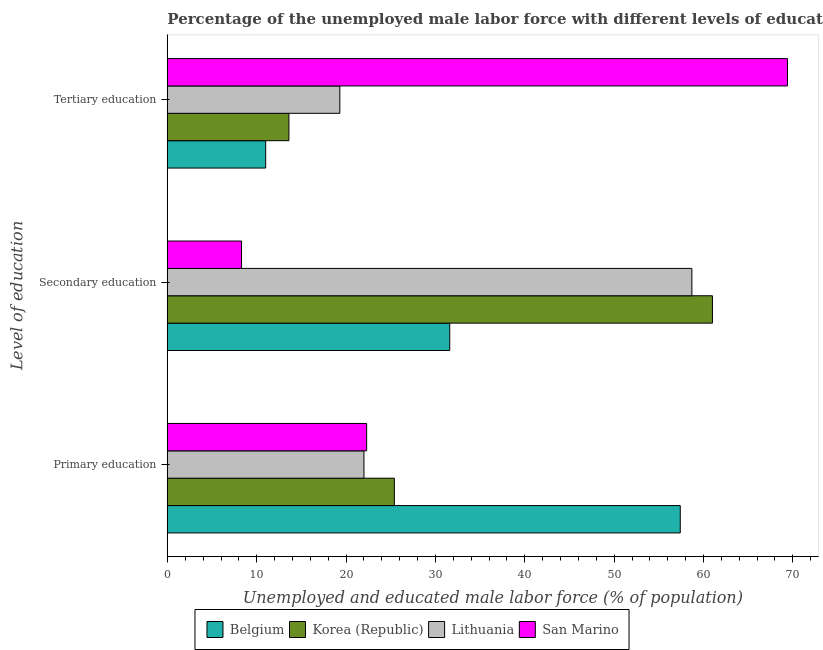How many groups of bars are there?
Make the answer very short. 3. Are the number of bars per tick equal to the number of legend labels?
Your answer should be compact. Yes. How many bars are there on the 3rd tick from the bottom?
Make the answer very short. 4. What is the label of the 1st group of bars from the top?
Provide a succinct answer. Tertiary education. What is the percentage of male labor force who received secondary education in Belgium?
Provide a succinct answer. 31.6. Across all countries, what is the maximum percentage of male labor force who received tertiary education?
Provide a short and direct response. 69.4. In which country was the percentage of male labor force who received primary education maximum?
Provide a succinct answer. Belgium. In which country was the percentage of male labor force who received tertiary education minimum?
Offer a terse response. Belgium. What is the total percentage of male labor force who received primary education in the graph?
Provide a succinct answer. 127.1. What is the difference between the percentage of male labor force who received secondary education in Belgium and that in Lithuania?
Offer a very short reply. -27.1. What is the difference between the percentage of male labor force who received secondary education in Lithuania and the percentage of male labor force who received primary education in Belgium?
Ensure brevity in your answer.  1.3. What is the average percentage of male labor force who received secondary education per country?
Keep it short and to the point. 39.9. What is the difference between the percentage of male labor force who received secondary education and percentage of male labor force who received primary education in Korea (Republic)?
Offer a very short reply. 35.6. In how many countries, is the percentage of male labor force who received primary education greater than 14 %?
Provide a succinct answer. 4. What is the ratio of the percentage of male labor force who received tertiary education in Belgium to that in Lithuania?
Your response must be concise. 0.57. Is the percentage of male labor force who received primary education in San Marino less than that in Korea (Republic)?
Ensure brevity in your answer.  Yes. What is the difference between the highest and the second highest percentage of male labor force who received primary education?
Ensure brevity in your answer.  32. What is the difference between the highest and the lowest percentage of male labor force who received tertiary education?
Give a very brief answer. 58.4. Is the sum of the percentage of male labor force who received tertiary education in Korea (Republic) and San Marino greater than the maximum percentage of male labor force who received primary education across all countries?
Give a very brief answer. Yes. What does the 4th bar from the bottom in Tertiary education represents?
Make the answer very short. San Marino. Is it the case that in every country, the sum of the percentage of male labor force who received primary education and percentage of male labor force who received secondary education is greater than the percentage of male labor force who received tertiary education?
Your response must be concise. No. Does the graph contain any zero values?
Keep it short and to the point. No. Does the graph contain grids?
Your response must be concise. No. Where does the legend appear in the graph?
Offer a terse response. Bottom center. How are the legend labels stacked?
Offer a very short reply. Horizontal. What is the title of the graph?
Make the answer very short. Percentage of the unemployed male labor force with different levels of education in countries. Does "Iran" appear as one of the legend labels in the graph?
Provide a short and direct response. No. What is the label or title of the X-axis?
Your response must be concise. Unemployed and educated male labor force (% of population). What is the label or title of the Y-axis?
Make the answer very short. Level of education. What is the Unemployed and educated male labor force (% of population) in Belgium in Primary education?
Provide a short and direct response. 57.4. What is the Unemployed and educated male labor force (% of population) of Korea (Republic) in Primary education?
Ensure brevity in your answer.  25.4. What is the Unemployed and educated male labor force (% of population) of Lithuania in Primary education?
Provide a short and direct response. 22. What is the Unemployed and educated male labor force (% of population) in San Marino in Primary education?
Your response must be concise. 22.3. What is the Unemployed and educated male labor force (% of population) of Belgium in Secondary education?
Ensure brevity in your answer.  31.6. What is the Unemployed and educated male labor force (% of population) in Lithuania in Secondary education?
Make the answer very short. 58.7. What is the Unemployed and educated male labor force (% of population) of San Marino in Secondary education?
Provide a short and direct response. 8.3. What is the Unemployed and educated male labor force (% of population) in Belgium in Tertiary education?
Your answer should be compact. 11. What is the Unemployed and educated male labor force (% of population) of Korea (Republic) in Tertiary education?
Ensure brevity in your answer.  13.6. What is the Unemployed and educated male labor force (% of population) of Lithuania in Tertiary education?
Offer a very short reply. 19.3. What is the Unemployed and educated male labor force (% of population) in San Marino in Tertiary education?
Ensure brevity in your answer.  69.4. Across all Level of education, what is the maximum Unemployed and educated male labor force (% of population) of Belgium?
Ensure brevity in your answer.  57.4. Across all Level of education, what is the maximum Unemployed and educated male labor force (% of population) of Korea (Republic)?
Offer a very short reply. 61. Across all Level of education, what is the maximum Unemployed and educated male labor force (% of population) of Lithuania?
Your answer should be very brief. 58.7. Across all Level of education, what is the maximum Unemployed and educated male labor force (% of population) of San Marino?
Ensure brevity in your answer.  69.4. Across all Level of education, what is the minimum Unemployed and educated male labor force (% of population) of Korea (Republic)?
Offer a terse response. 13.6. Across all Level of education, what is the minimum Unemployed and educated male labor force (% of population) of Lithuania?
Offer a very short reply. 19.3. Across all Level of education, what is the minimum Unemployed and educated male labor force (% of population) in San Marino?
Offer a very short reply. 8.3. What is the total Unemployed and educated male labor force (% of population) of Belgium in the graph?
Give a very brief answer. 100. What is the total Unemployed and educated male labor force (% of population) of Lithuania in the graph?
Provide a short and direct response. 100. What is the total Unemployed and educated male labor force (% of population) in San Marino in the graph?
Your response must be concise. 100. What is the difference between the Unemployed and educated male labor force (% of population) of Belgium in Primary education and that in Secondary education?
Offer a terse response. 25.8. What is the difference between the Unemployed and educated male labor force (% of population) in Korea (Republic) in Primary education and that in Secondary education?
Offer a very short reply. -35.6. What is the difference between the Unemployed and educated male labor force (% of population) of Lithuania in Primary education and that in Secondary education?
Ensure brevity in your answer.  -36.7. What is the difference between the Unemployed and educated male labor force (% of population) of San Marino in Primary education and that in Secondary education?
Provide a short and direct response. 14. What is the difference between the Unemployed and educated male labor force (% of population) of Belgium in Primary education and that in Tertiary education?
Offer a very short reply. 46.4. What is the difference between the Unemployed and educated male labor force (% of population) in Korea (Republic) in Primary education and that in Tertiary education?
Give a very brief answer. 11.8. What is the difference between the Unemployed and educated male labor force (% of population) in San Marino in Primary education and that in Tertiary education?
Provide a short and direct response. -47.1. What is the difference between the Unemployed and educated male labor force (% of population) in Belgium in Secondary education and that in Tertiary education?
Offer a very short reply. 20.6. What is the difference between the Unemployed and educated male labor force (% of population) of Korea (Republic) in Secondary education and that in Tertiary education?
Provide a short and direct response. 47.4. What is the difference between the Unemployed and educated male labor force (% of population) of Lithuania in Secondary education and that in Tertiary education?
Your answer should be very brief. 39.4. What is the difference between the Unemployed and educated male labor force (% of population) of San Marino in Secondary education and that in Tertiary education?
Provide a succinct answer. -61.1. What is the difference between the Unemployed and educated male labor force (% of population) in Belgium in Primary education and the Unemployed and educated male labor force (% of population) in San Marino in Secondary education?
Offer a terse response. 49.1. What is the difference between the Unemployed and educated male labor force (% of population) of Korea (Republic) in Primary education and the Unemployed and educated male labor force (% of population) of Lithuania in Secondary education?
Provide a short and direct response. -33.3. What is the difference between the Unemployed and educated male labor force (% of population) of Korea (Republic) in Primary education and the Unemployed and educated male labor force (% of population) of San Marino in Secondary education?
Keep it short and to the point. 17.1. What is the difference between the Unemployed and educated male labor force (% of population) in Lithuania in Primary education and the Unemployed and educated male labor force (% of population) in San Marino in Secondary education?
Make the answer very short. 13.7. What is the difference between the Unemployed and educated male labor force (% of population) in Belgium in Primary education and the Unemployed and educated male labor force (% of population) in Korea (Republic) in Tertiary education?
Offer a very short reply. 43.8. What is the difference between the Unemployed and educated male labor force (% of population) of Belgium in Primary education and the Unemployed and educated male labor force (% of population) of Lithuania in Tertiary education?
Offer a very short reply. 38.1. What is the difference between the Unemployed and educated male labor force (% of population) of Belgium in Primary education and the Unemployed and educated male labor force (% of population) of San Marino in Tertiary education?
Your answer should be very brief. -12. What is the difference between the Unemployed and educated male labor force (% of population) in Korea (Republic) in Primary education and the Unemployed and educated male labor force (% of population) in Lithuania in Tertiary education?
Offer a very short reply. 6.1. What is the difference between the Unemployed and educated male labor force (% of population) of Korea (Republic) in Primary education and the Unemployed and educated male labor force (% of population) of San Marino in Tertiary education?
Your answer should be compact. -44. What is the difference between the Unemployed and educated male labor force (% of population) in Lithuania in Primary education and the Unemployed and educated male labor force (% of population) in San Marino in Tertiary education?
Offer a very short reply. -47.4. What is the difference between the Unemployed and educated male labor force (% of population) in Belgium in Secondary education and the Unemployed and educated male labor force (% of population) in San Marino in Tertiary education?
Keep it short and to the point. -37.8. What is the difference between the Unemployed and educated male labor force (% of population) of Korea (Republic) in Secondary education and the Unemployed and educated male labor force (% of population) of Lithuania in Tertiary education?
Keep it short and to the point. 41.7. What is the difference between the Unemployed and educated male labor force (% of population) of Korea (Republic) in Secondary education and the Unemployed and educated male labor force (% of population) of San Marino in Tertiary education?
Give a very brief answer. -8.4. What is the average Unemployed and educated male labor force (% of population) in Belgium per Level of education?
Provide a short and direct response. 33.33. What is the average Unemployed and educated male labor force (% of population) in Korea (Republic) per Level of education?
Keep it short and to the point. 33.33. What is the average Unemployed and educated male labor force (% of population) in Lithuania per Level of education?
Keep it short and to the point. 33.33. What is the average Unemployed and educated male labor force (% of population) in San Marino per Level of education?
Your answer should be compact. 33.33. What is the difference between the Unemployed and educated male labor force (% of population) of Belgium and Unemployed and educated male labor force (% of population) of Korea (Republic) in Primary education?
Your answer should be compact. 32. What is the difference between the Unemployed and educated male labor force (% of population) of Belgium and Unemployed and educated male labor force (% of population) of Lithuania in Primary education?
Keep it short and to the point. 35.4. What is the difference between the Unemployed and educated male labor force (% of population) in Belgium and Unemployed and educated male labor force (% of population) in San Marino in Primary education?
Make the answer very short. 35.1. What is the difference between the Unemployed and educated male labor force (% of population) of Belgium and Unemployed and educated male labor force (% of population) of Korea (Republic) in Secondary education?
Offer a very short reply. -29.4. What is the difference between the Unemployed and educated male labor force (% of population) in Belgium and Unemployed and educated male labor force (% of population) in Lithuania in Secondary education?
Provide a succinct answer. -27.1. What is the difference between the Unemployed and educated male labor force (% of population) in Belgium and Unemployed and educated male labor force (% of population) in San Marino in Secondary education?
Offer a terse response. 23.3. What is the difference between the Unemployed and educated male labor force (% of population) of Korea (Republic) and Unemployed and educated male labor force (% of population) of San Marino in Secondary education?
Provide a succinct answer. 52.7. What is the difference between the Unemployed and educated male labor force (% of population) of Lithuania and Unemployed and educated male labor force (% of population) of San Marino in Secondary education?
Offer a terse response. 50.4. What is the difference between the Unemployed and educated male labor force (% of population) in Belgium and Unemployed and educated male labor force (% of population) in Lithuania in Tertiary education?
Your answer should be very brief. -8.3. What is the difference between the Unemployed and educated male labor force (% of population) in Belgium and Unemployed and educated male labor force (% of population) in San Marino in Tertiary education?
Make the answer very short. -58.4. What is the difference between the Unemployed and educated male labor force (% of population) of Korea (Republic) and Unemployed and educated male labor force (% of population) of San Marino in Tertiary education?
Provide a succinct answer. -55.8. What is the difference between the Unemployed and educated male labor force (% of population) of Lithuania and Unemployed and educated male labor force (% of population) of San Marino in Tertiary education?
Make the answer very short. -50.1. What is the ratio of the Unemployed and educated male labor force (% of population) of Belgium in Primary education to that in Secondary education?
Ensure brevity in your answer.  1.82. What is the ratio of the Unemployed and educated male labor force (% of population) in Korea (Republic) in Primary education to that in Secondary education?
Ensure brevity in your answer.  0.42. What is the ratio of the Unemployed and educated male labor force (% of population) in Lithuania in Primary education to that in Secondary education?
Keep it short and to the point. 0.37. What is the ratio of the Unemployed and educated male labor force (% of population) of San Marino in Primary education to that in Secondary education?
Keep it short and to the point. 2.69. What is the ratio of the Unemployed and educated male labor force (% of population) in Belgium in Primary education to that in Tertiary education?
Give a very brief answer. 5.22. What is the ratio of the Unemployed and educated male labor force (% of population) in Korea (Republic) in Primary education to that in Tertiary education?
Give a very brief answer. 1.87. What is the ratio of the Unemployed and educated male labor force (% of population) of Lithuania in Primary education to that in Tertiary education?
Give a very brief answer. 1.14. What is the ratio of the Unemployed and educated male labor force (% of population) of San Marino in Primary education to that in Tertiary education?
Your answer should be very brief. 0.32. What is the ratio of the Unemployed and educated male labor force (% of population) of Belgium in Secondary education to that in Tertiary education?
Your response must be concise. 2.87. What is the ratio of the Unemployed and educated male labor force (% of population) in Korea (Republic) in Secondary education to that in Tertiary education?
Make the answer very short. 4.49. What is the ratio of the Unemployed and educated male labor force (% of population) in Lithuania in Secondary education to that in Tertiary education?
Provide a short and direct response. 3.04. What is the ratio of the Unemployed and educated male labor force (% of population) of San Marino in Secondary education to that in Tertiary education?
Keep it short and to the point. 0.12. What is the difference between the highest and the second highest Unemployed and educated male labor force (% of population) in Belgium?
Offer a very short reply. 25.8. What is the difference between the highest and the second highest Unemployed and educated male labor force (% of population) of Korea (Republic)?
Your response must be concise. 35.6. What is the difference between the highest and the second highest Unemployed and educated male labor force (% of population) of Lithuania?
Offer a terse response. 36.7. What is the difference between the highest and the second highest Unemployed and educated male labor force (% of population) in San Marino?
Your response must be concise. 47.1. What is the difference between the highest and the lowest Unemployed and educated male labor force (% of population) of Belgium?
Provide a succinct answer. 46.4. What is the difference between the highest and the lowest Unemployed and educated male labor force (% of population) of Korea (Republic)?
Provide a succinct answer. 47.4. What is the difference between the highest and the lowest Unemployed and educated male labor force (% of population) of Lithuania?
Your response must be concise. 39.4. What is the difference between the highest and the lowest Unemployed and educated male labor force (% of population) in San Marino?
Make the answer very short. 61.1. 